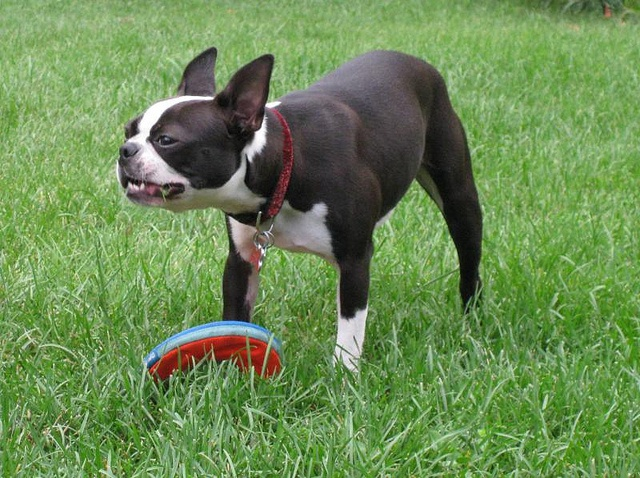Describe the objects in this image and their specific colors. I can see dog in lightgreen, black, gray, and darkgray tones and frisbee in lightgreen, maroon, brown, and lightblue tones in this image. 